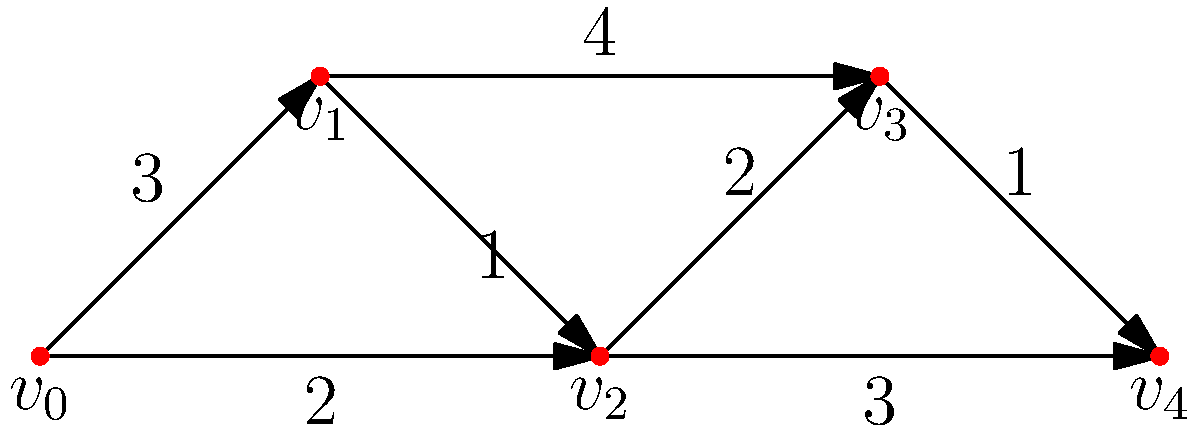As the bureau chief optimizing news delivery routes, you're analyzing a network of cities represented by the graph above. Each edge represents a direct connection between cities, with the weight indicating the time (in hours) to transmit news between them. What is the shortest time required to transmit breaking news from city $v_0$ to city $v_4$ using Dijkstra's algorithm? To solve this problem using Dijkstra's algorithm, we'll follow these steps:

1) Initialize:
   - Set distance to $v_0$ as 0
   - Set distances to all other vertices as infinity
   - Set all vertices as unvisited

2) For the current vertex (starting with $v_0$), consider all unvisited neighbors and calculate their tentative distances.
   
3) When we're done considering all neighbors of the current vertex, mark it as visited.
   
4) If the destination vertex ($v_4$) has been marked visited, we're done. Otherwise, select the unvisited vertex with the smallest tentative distance and set it as the new current vertex. Go back to step 2.

Step-by-step process:

1) Start: $v_0$ (0), $v_1$ (∞), $v_2$ (∞), $v_3$ (∞), $v_4$ (∞)
   
2) From $v_0$:
   - To $v_1$: 0 + 3 = 3
   - To $v_2$: 0 + 2 = 2
   Updated: $v_0$ (0), $v_1$ (3), $v_2$ (2), $v_3$ (∞), $v_4$ (∞)
   
3) Visit $v_2$ (smallest unvisited):
   - To $v_1$: 2 + 1 = 3 (no update)
   - To $v_3$: 2 + 2 = 4
   - To $v_4$: 2 + 3 = 5
   Updated: $v_0$ (0), $v_1$ (3), $v_2$ (2), $v_3$ (4), $v_4$ (5)
   
4) Visit $v_1$:
   - To $v_3$: 3 + 4 = 7 (no update)
   
5) Visit $v_3$:
   - To $v_4$: 4 + 1 = 5 (no update)
   
6) Visit $v_4$ (destination reached)

The shortest path is $v_0 \rightarrow v_2 \rightarrow v_4$ with a total time of 5 hours.
Answer: 5 hours 